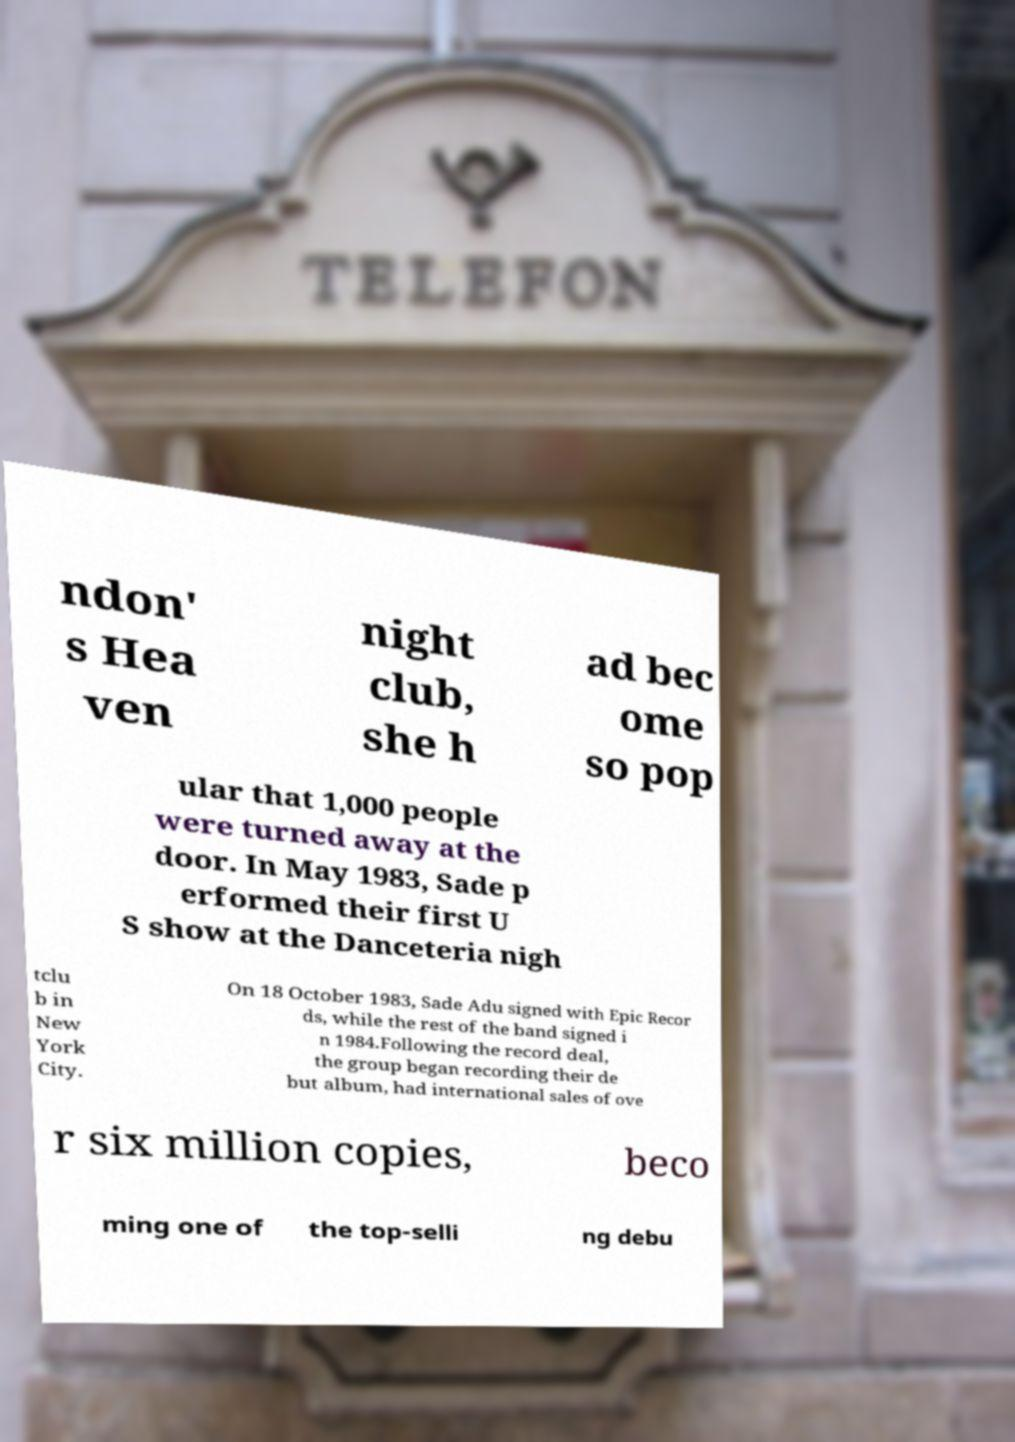For documentation purposes, I need the text within this image transcribed. Could you provide that? ndon' s Hea ven night club, she h ad bec ome so pop ular that 1,000 people were turned away at the door. In May 1983, Sade p erformed their first U S show at the Danceteria nigh tclu b in New York City. On 18 October 1983, Sade Adu signed with Epic Recor ds, while the rest of the band signed i n 1984.Following the record deal, the group began recording their de but album, had international sales of ove r six million copies, beco ming one of the top-selli ng debu 